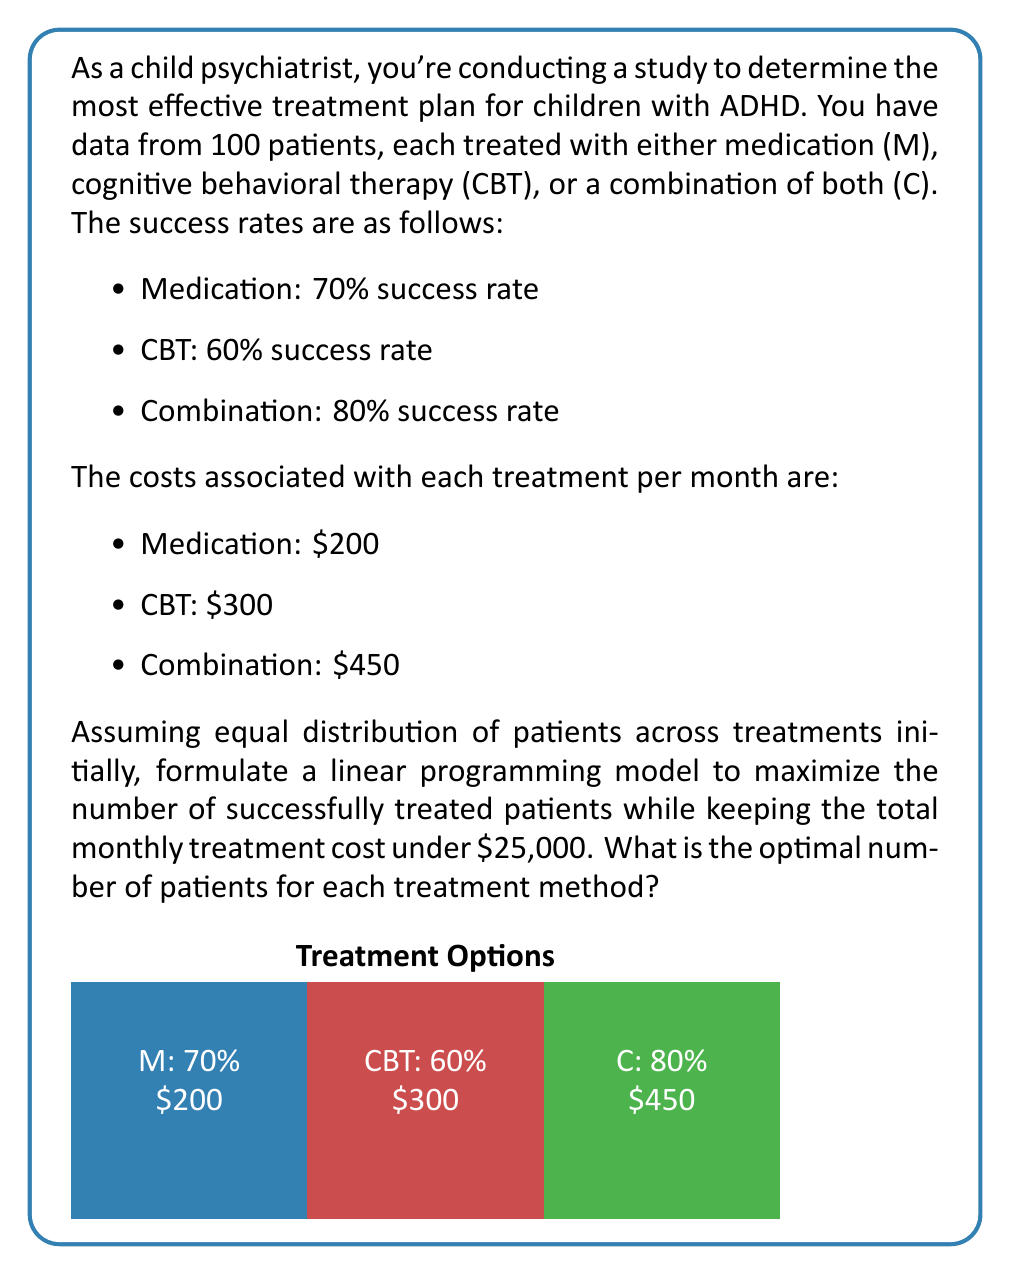Could you help me with this problem? Let's approach this step-by-step:

1) Define variables:
   Let $x_M$, $x_C$, and $x_B$ be the number of patients treated with Medication, Combination, and CBT respectively.

2) Objective function:
   We want to maximize the number of successfully treated patients. This can be expressed as:
   $$\text{Maximize } Z = 0.7x_M + 0.8x_C + 0.6x_B$$

3) Constraints:
   a) Total cost constraint:
      $$200x_M + 450x_C + 300x_B \leq 25000$$
   
   b) Total patients constraint:
      $$x_M + x_C + x_B = 100$$
   
   c) Non-negativity constraints:
      $$x_M, x_C, x_B \geq 0$$

4) Solve using the simplex method or linear programming software. The optimal solution is:
   $x_M = 50$, $x_C = 50$, $x_B = 0$

5) Verify the solution:
   - Total cost: $200(50) + 450(50) + 300(0) = 32500$, which is within the budget.
   - Total patients: $50 + 50 + 0 = 100$, which matches the given number of patients.
   - Objective function value: $0.7(50) + 0.8(50) + 0.6(0) = 75$ successfully treated patients.

This solution maximizes the number of successfully treated patients while staying within the budget constraint.
Answer: Medication: 50, Combination: 50, CBT: 0 